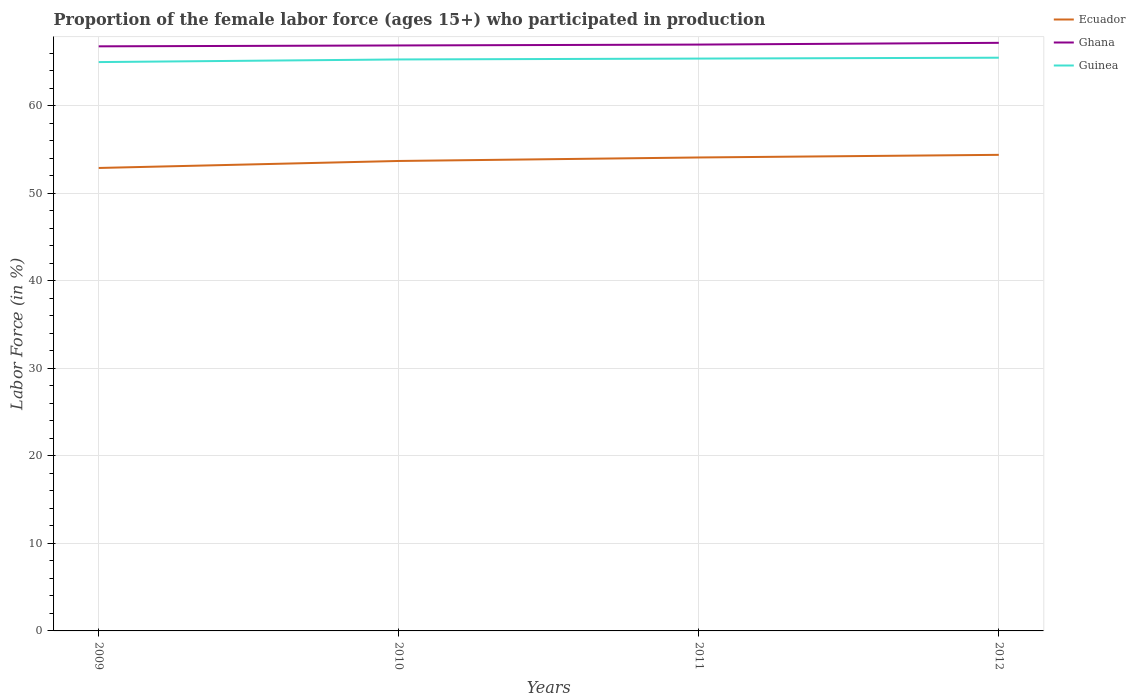How many different coloured lines are there?
Your answer should be very brief. 3. What is the total proportion of the female labor force who participated in production in Ecuador in the graph?
Offer a very short reply. -1.2. What is the difference between the highest and the lowest proportion of the female labor force who participated in production in Ghana?
Your answer should be compact. 2. How many lines are there?
Give a very brief answer. 3. How many years are there in the graph?
Your answer should be compact. 4. Are the values on the major ticks of Y-axis written in scientific E-notation?
Offer a very short reply. No. Does the graph contain grids?
Provide a short and direct response. Yes. How many legend labels are there?
Your answer should be compact. 3. How are the legend labels stacked?
Your answer should be very brief. Vertical. What is the title of the graph?
Offer a very short reply. Proportion of the female labor force (ages 15+) who participated in production. What is the label or title of the X-axis?
Make the answer very short. Years. What is the label or title of the Y-axis?
Your response must be concise. Labor Force (in %). What is the Labor Force (in %) of Ecuador in 2009?
Keep it short and to the point. 52.9. What is the Labor Force (in %) in Ghana in 2009?
Your response must be concise. 66.8. What is the Labor Force (in %) of Ecuador in 2010?
Your answer should be very brief. 53.7. What is the Labor Force (in %) in Ghana in 2010?
Keep it short and to the point. 66.9. What is the Labor Force (in %) in Guinea in 2010?
Your answer should be very brief. 65.3. What is the Labor Force (in %) in Ecuador in 2011?
Your answer should be compact. 54.1. What is the Labor Force (in %) of Ghana in 2011?
Your response must be concise. 67. What is the Labor Force (in %) of Guinea in 2011?
Ensure brevity in your answer.  65.4. What is the Labor Force (in %) in Ecuador in 2012?
Your answer should be compact. 54.4. What is the Labor Force (in %) of Ghana in 2012?
Ensure brevity in your answer.  67.2. What is the Labor Force (in %) of Guinea in 2012?
Ensure brevity in your answer.  65.5. Across all years, what is the maximum Labor Force (in %) in Ecuador?
Offer a very short reply. 54.4. Across all years, what is the maximum Labor Force (in %) of Ghana?
Offer a very short reply. 67.2. Across all years, what is the maximum Labor Force (in %) in Guinea?
Your response must be concise. 65.5. Across all years, what is the minimum Labor Force (in %) in Ecuador?
Your answer should be very brief. 52.9. Across all years, what is the minimum Labor Force (in %) in Ghana?
Provide a short and direct response. 66.8. What is the total Labor Force (in %) of Ecuador in the graph?
Your response must be concise. 215.1. What is the total Labor Force (in %) in Ghana in the graph?
Offer a very short reply. 267.9. What is the total Labor Force (in %) of Guinea in the graph?
Keep it short and to the point. 261.2. What is the difference between the Labor Force (in %) of Ecuador in 2009 and that in 2010?
Offer a terse response. -0.8. What is the difference between the Labor Force (in %) of Ghana in 2009 and that in 2010?
Your answer should be very brief. -0.1. What is the difference between the Labor Force (in %) in Guinea in 2009 and that in 2010?
Provide a succinct answer. -0.3. What is the difference between the Labor Force (in %) in Ecuador in 2009 and that in 2011?
Your answer should be very brief. -1.2. What is the difference between the Labor Force (in %) of Ghana in 2009 and that in 2011?
Provide a short and direct response. -0.2. What is the difference between the Labor Force (in %) in Guinea in 2009 and that in 2011?
Your response must be concise. -0.4. What is the difference between the Labor Force (in %) in Ghana in 2009 and that in 2012?
Provide a short and direct response. -0.4. What is the difference between the Labor Force (in %) in Guinea in 2009 and that in 2012?
Ensure brevity in your answer.  -0.5. What is the difference between the Labor Force (in %) of Ecuador in 2010 and that in 2011?
Provide a short and direct response. -0.4. What is the difference between the Labor Force (in %) of Ghana in 2010 and that in 2011?
Ensure brevity in your answer.  -0.1. What is the difference between the Labor Force (in %) of Ghana in 2010 and that in 2012?
Provide a short and direct response. -0.3. What is the difference between the Labor Force (in %) of Guinea in 2010 and that in 2012?
Keep it short and to the point. -0.2. What is the difference between the Labor Force (in %) of Ghana in 2011 and that in 2012?
Offer a terse response. -0.2. What is the difference between the Labor Force (in %) in Guinea in 2011 and that in 2012?
Provide a short and direct response. -0.1. What is the difference between the Labor Force (in %) in Ecuador in 2009 and the Labor Force (in %) in Ghana in 2011?
Your answer should be compact. -14.1. What is the difference between the Labor Force (in %) of Ghana in 2009 and the Labor Force (in %) of Guinea in 2011?
Offer a very short reply. 1.4. What is the difference between the Labor Force (in %) in Ecuador in 2009 and the Labor Force (in %) in Ghana in 2012?
Your answer should be very brief. -14.3. What is the difference between the Labor Force (in %) of Ecuador in 2009 and the Labor Force (in %) of Guinea in 2012?
Your answer should be compact. -12.6. What is the difference between the Labor Force (in %) in Ecuador in 2010 and the Labor Force (in %) in Ghana in 2011?
Your answer should be compact. -13.3. What is the difference between the Labor Force (in %) of Ecuador in 2010 and the Labor Force (in %) of Guinea in 2011?
Provide a short and direct response. -11.7. What is the difference between the Labor Force (in %) in Ecuador in 2010 and the Labor Force (in %) in Ghana in 2012?
Your response must be concise. -13.5. What is the difference between the Labor Force (in %) in Ghana in 2010 and the Labor Force (in %) in Guinea in 2012?
Your response must be concise. 1.4. What is the difference between the Labor Force (in %) of Ecuador in 2011 and the Labor Force (in %) of Ghana in 2012?
Keep it short and to the point. -13.1. What is the difference between the Labor Force (in %) of Ghana in 2011 and the Labor Force (in %) of Guinea in 2012?
Give a very brief answer. 1.5. What is the average Labor Force (in %) of Ecuador per year?
Offer a very short reply. 53.77. What is the average Labor Force (in %) in Ghana per year?
Offer a terse response. 66.97. What is the average Labor Force (in %) of Guinea per year?
Ensure brevity in your answer.  65.3. In the year 2009, what is the difference between the Labor Force (in %) of Ecuador and Labor Force (in %) of Ghana?
Your answer should be very brief. -13.9. In the year 2009, what is the difference between the Labor Force (in %) in Ecuador and Labor Force (in %) in Guinea?
Your response must be concise. -12.1. In the year 2010, what is the difference between the Labor Force (in %) in Ecuador and Labor Force (in %) in Guinea?
Your answer should be compact. -11.6. In the year 2010, what is the difference between the Labor Force (in %) of Ghana and Labor Force (in %) of Guinea?
Make the answer very short. 1.6. In the year 2012, what is the difference between the Labor Force (in %) in Ecuador and Labor Force (in %) in Ghana?
Provide a short and direct response. -12.8. What is the ratio of the Labor Force (in %) in Ecuador in 2009 to that in 2010?
Offer a very short reply. 0.99. What is the ratio of the Labor Force (in %) in Guinea in 2009 to that in 2010?
Your answer should be compact. 1. What is the ratio of the Labor Force (in %) of Ecuador in 2009 to that in 2011?
Your response must be concise. 0.98. What is the ratio of the Labor Force (in %) in Ghana in 2009 to that in 2011?
Your answer should be very brief. 1. What is the ratio of the Labor Force (in %) in Guinea in 2009 to that in 2011?
Your answer should be compact. 0.99. What is the ratio of the Labor Force (in %) of Ecuador in 2009 to that in 2012?
Offer a very short reply. 0.97. What is the ratio of the Labor Force (in %) of Ghana in 2009 to that in 2012?
Offer a very short reply. 0.99. What is the ratio of the Labor Force (in %) of Ecuador in 2010 to that in 2011?
Provide a short and direct response. 0.99. What is the ratio of the Labor Force (in %) in Guinea in 2010 to that in 2011?
Ensure brevity in your answer.  1. What is the ratio of the Labor Force (in %) in Ecuador in 2010 to that in 2012?
Your answer should be compact. 0.99. What is the ratio of the Labor Force (in %) of Ghana in 2010 to that in 2012?
Your answer should be compact. 1. What is the ratio of the Labor Force (in %) of Ghana in 2011 to that in 2012?
Provide a succinct answer. 1. What is the ratio of the Labor Force (in %) in Guinea in 2011 to that in 2012?
Your answer should be very brief. 1. What is the difference between the highest and the second highest Labor Force (in %) of Ecuador?
Offer a very short reply. 0.3. 